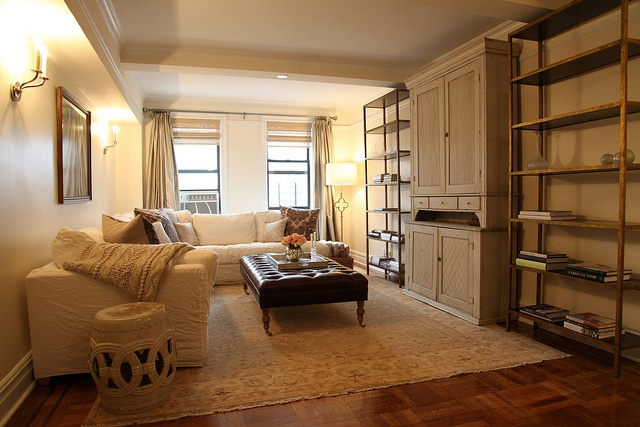Describe the objects in this image and their specific colors. I can see couch in lightyellow, maroon, brown, and tan tones, couch in lightyellow, tan, and lightgray tones, book in lightyellow, black, maroon, and gray tones, book in lightyellow, maroon, black, and brown tones, and book in lightyellow, black, maroon, and brown tones in this image. 